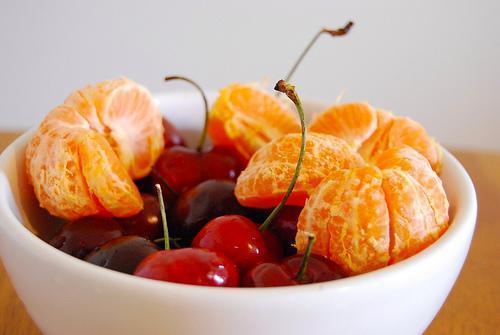What is contained in the red fruit that should not be ingested?
Answer the question by selecting the correct answer among the 4 following choices and explain your choice with a short sentence. The answer should be formatted with the following format: `Answer: choice
Rationale: rationale.`
Options: Skin, sticks, juice, seed. Answer: seed.
Rationale: The fruit is a cherry and contains a pit in the center. 